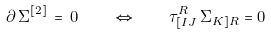<formula> <loc_0><loc_0><loc_500><loc_500>\partial \, \Sigma ^ { [ 2 ] } \, = \, 0 \quad \Leftrightarrow \quad \tau ^ { R } _ { [ I J } \, \Sigma _ { K ] R } = 0</formula> 